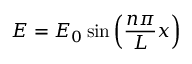Convert formula to latex. <formula><loc_0><loc_0><loc_500><loc_500>E = E _ { 0 } \sin \left ( { \frac { n \pi } { L } } x \right ) \,</formula> 